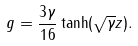<formula> <loc_0><loc_0><loc_500><loc_500>g = \frac { 3 \gamma } { 1 6 } \tanh ( \sqrt { \gamma } z ) .</formula> 